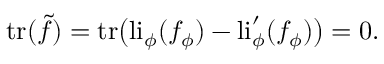Convert formula to latex. <formula><loc_0><loc_0><loc_500><loc_500>t r ( \tilde { f } ) = t r \left ( l i _ { \phi } ( f _ { \phi } ) - l i _ { \phi } ^ { \prime } ( f _ { \phi } ) \right ) = 0 .</formula> 